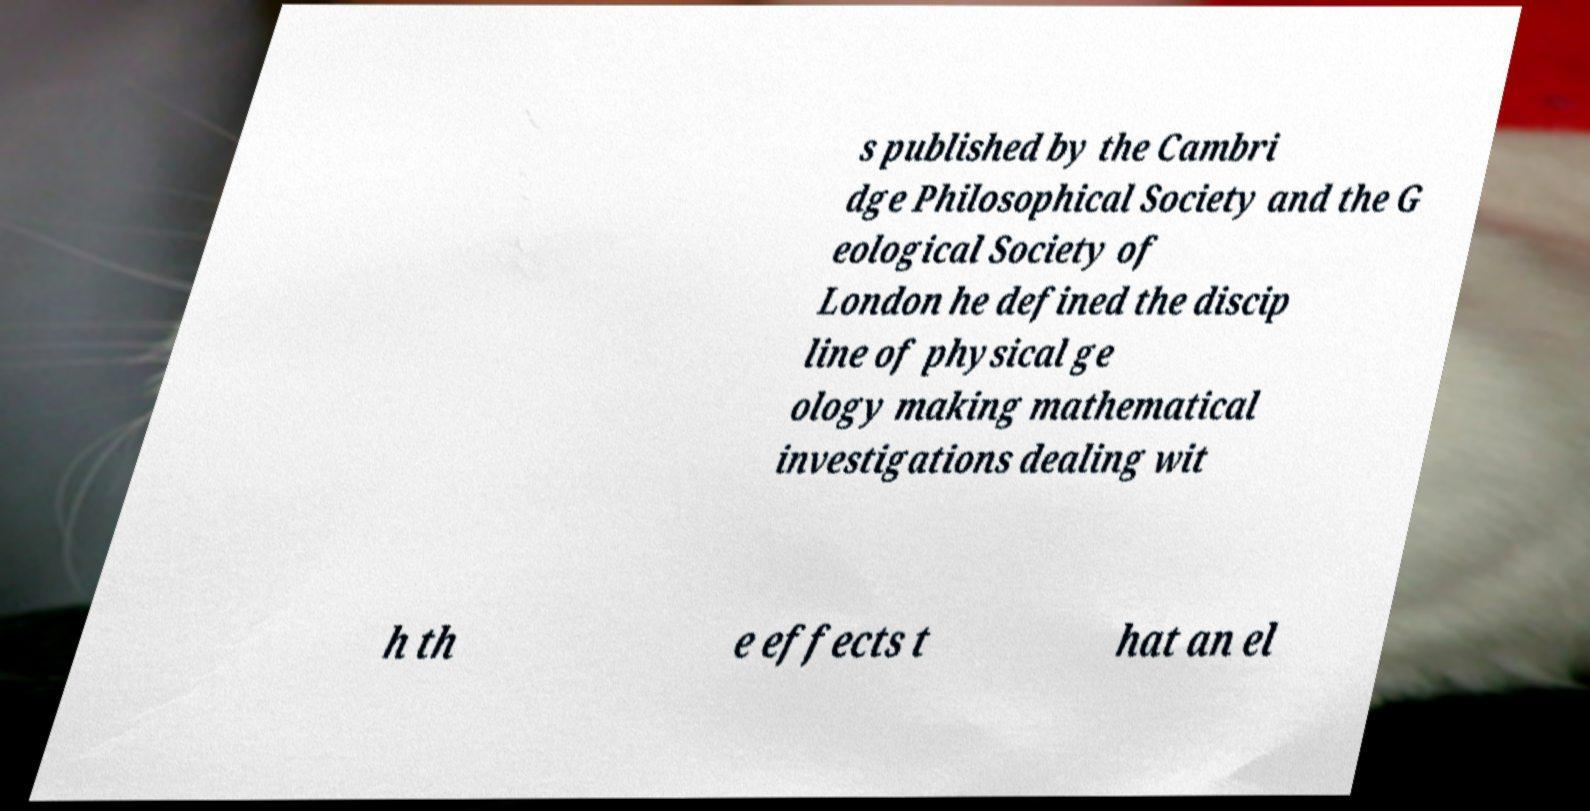Please identify and transcribe the text found in this image. s published by the Cambri dge Philosophical Society and the G eological Society of London he defined the discip line of physical ge ology making mathematical investigations dealing wit h th e effects t hat an el 